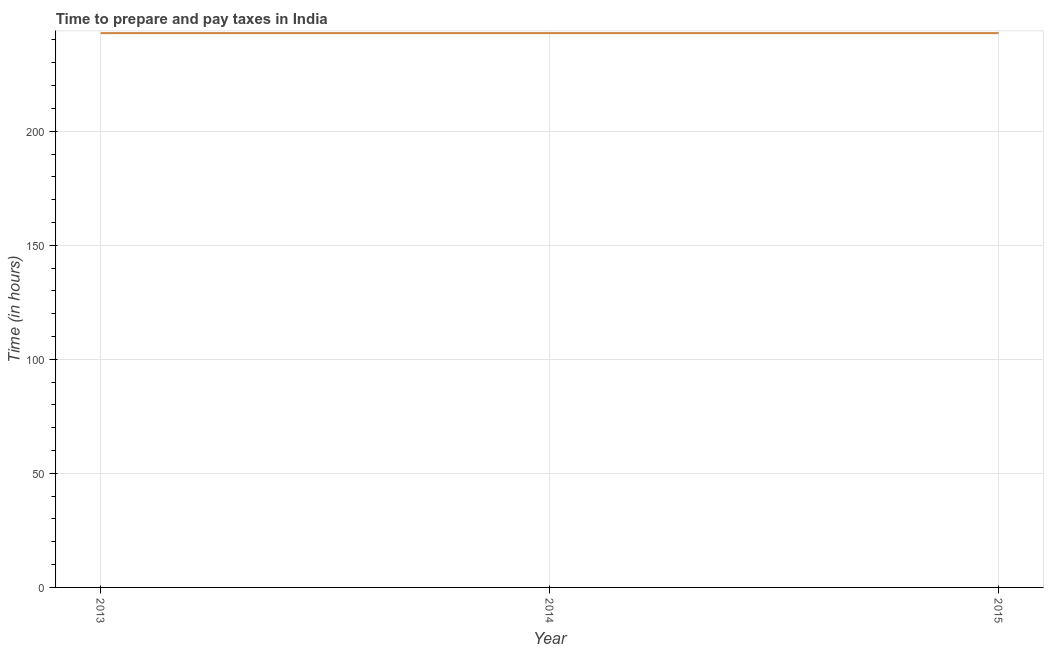What is the time to prepare and pay taxes in 2015?
Make the answer very short. 243. Across all years, what is the maximum time to prepare and pay taxes?
Ensure brevity in your answer.  243. Across all years, what is the minimum time to prepare and pay taxes?
Provide a short and direct response. 243. What is the sum of the time to prepare and pay taxes?
Provide a succinct answer. 729. What is the difference between the time to prepare and pay taxes in 2013 and 2014?
Give a very brief answer. 0. What is the average time to prepare and pay taxes per year?
Offer a very short reply. 243. What is the median time to prepare and pay taxes?
Provide a short and direct response. 243. In how many years, is the time to prepare and pay taxes greater than 80 hours?
Offer a terse response. 3. Do a majority of the years between 2013 and 2015 (inclusive) have time to prepare and pay taxes greater than 20 hours?
Provide a short and direct response. Yes. What is the ratio of the time to prepare and pay taxes in 2014 to that in 2015?
Your answer should be compact. 1. Is the time to prepare and pay taxes in 2013 less than that in 2014?
Make the answer very short. No. What is the difference between the highest and the second highest time to prepare and pay taxes?
Provide a succinct answer. 0. Is the sum of the time to prepare and pay taxes in 2014 and 2015 greater than the maximum time to prepare and pay taxes across all years?
Provide a short and direct response. Yes. What is the difference between the highest and the lowest time to prepare and pay taxes?
Offer a terse response. 0. In how many years, is the time to prepare and pay taxes greater than the average time to prepare and pay taxes taken over all years?
Offer a very short reply. 0. How many lines are there?
Give a very brief answer. 1. Does the graph contain grids?
Provide a succinct answer. Yes. What is the title of the graph?
Your answer should be compact. Time to prepare and pay taxes in India. What is the label or title of the X-axis?
Provide a short and direct response. Year. What is the label or title of the Y-axis?
Your response must be concise. Time (in hours). What is the Time (in hours) in 2013?
Offer a terse response. 243. What is the Time (in hours) of 2014?
Your answer should be very brief. 243. What is the Time (in hours) of 2015?
Provide a succinct answer. 243. What is the difference between the Time (in hours) in 2013 and 2014?
Provide a succinct answer. 0. What is the difference between the Time (in hours) in 2014 and 2015?
Your answer should be very brief. 0. What is the ratio of the Time (in hours) in 2014 to that in 2015?
Provide a succinct answer. 1. 